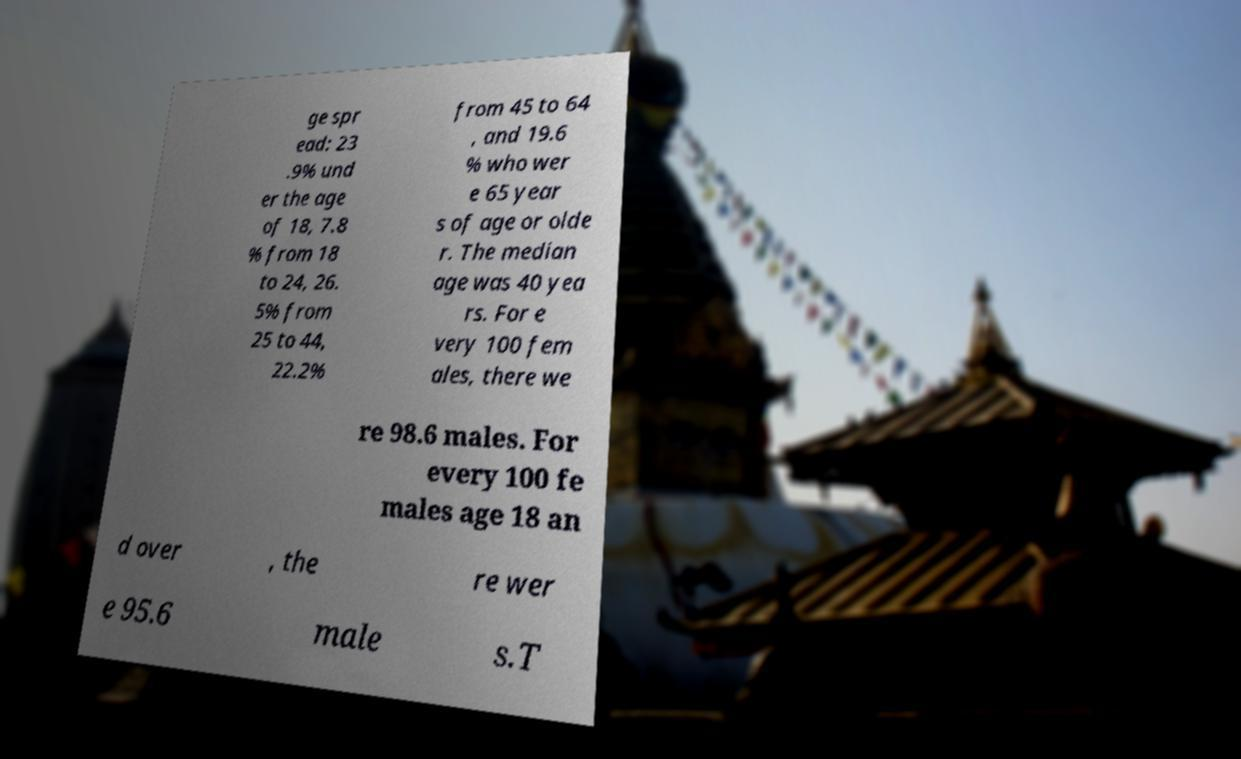For documentation purposes, I need the text within this image transcribed. Could you provide that? ge spr ead: 23 .9% und er the age of 18, 7.8 % from 18 to 24, 26. 5% from 25 to 44, 22.2% from 45 to 64 , and 19.6 % who wer e 65 year s of age or olde r. The median age was 40 yea rs. For e very 100 fem ales, there we re 98.6 males. For every 100 fe males age 18 an d over , the re wer e 95.6 male s.T 